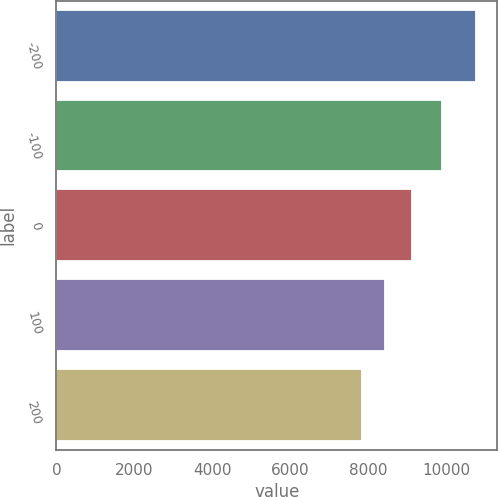Convert chart to OTSL. <chart><loc_0><loc_0><loc_500><loc_500><bar_chart><fcel>-200<fcel>-100<fcel>0<fcel>100<fcel>200<nl><fcel>10777<fcel>9901<fcel>9127<fcel>8439<fcel>7837<nl></chart> 